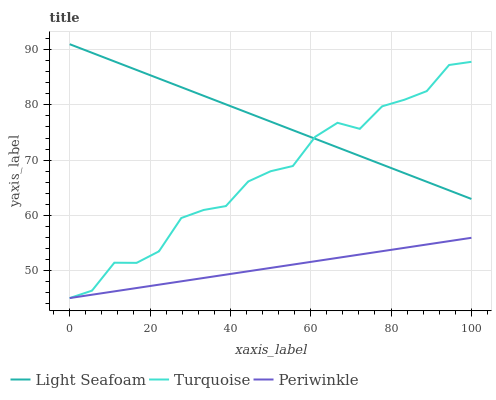Does Light Seafoam have the minimum area under the curve?
Answer yes or no. No. Does Periwinkle have the maximum area under the curve?
Answer yes or no. No. Is Light Seafoam the smoothest?
Answer yes or no. No. Is Light Seafoam the roughest?
Answer yes or no. No. Does Light Seafoam have the lowest value?
Answer yes or no. No. Does Periwinkle have the highest value?
Answer yes or no. No. Is Periwinkle less than Light Seafoam?
Answer yes or no. Yes. Is Light Seafoam greater than Periwinkle?
Answer yes or no. Yes. Does Periwinkle intersect Light Seafoam?
Answer yes or no. No. 